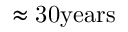<formula> <loc_0><loc_0><loc_500><loc_500>\approx { 3 0 y e a r s }</formula> 